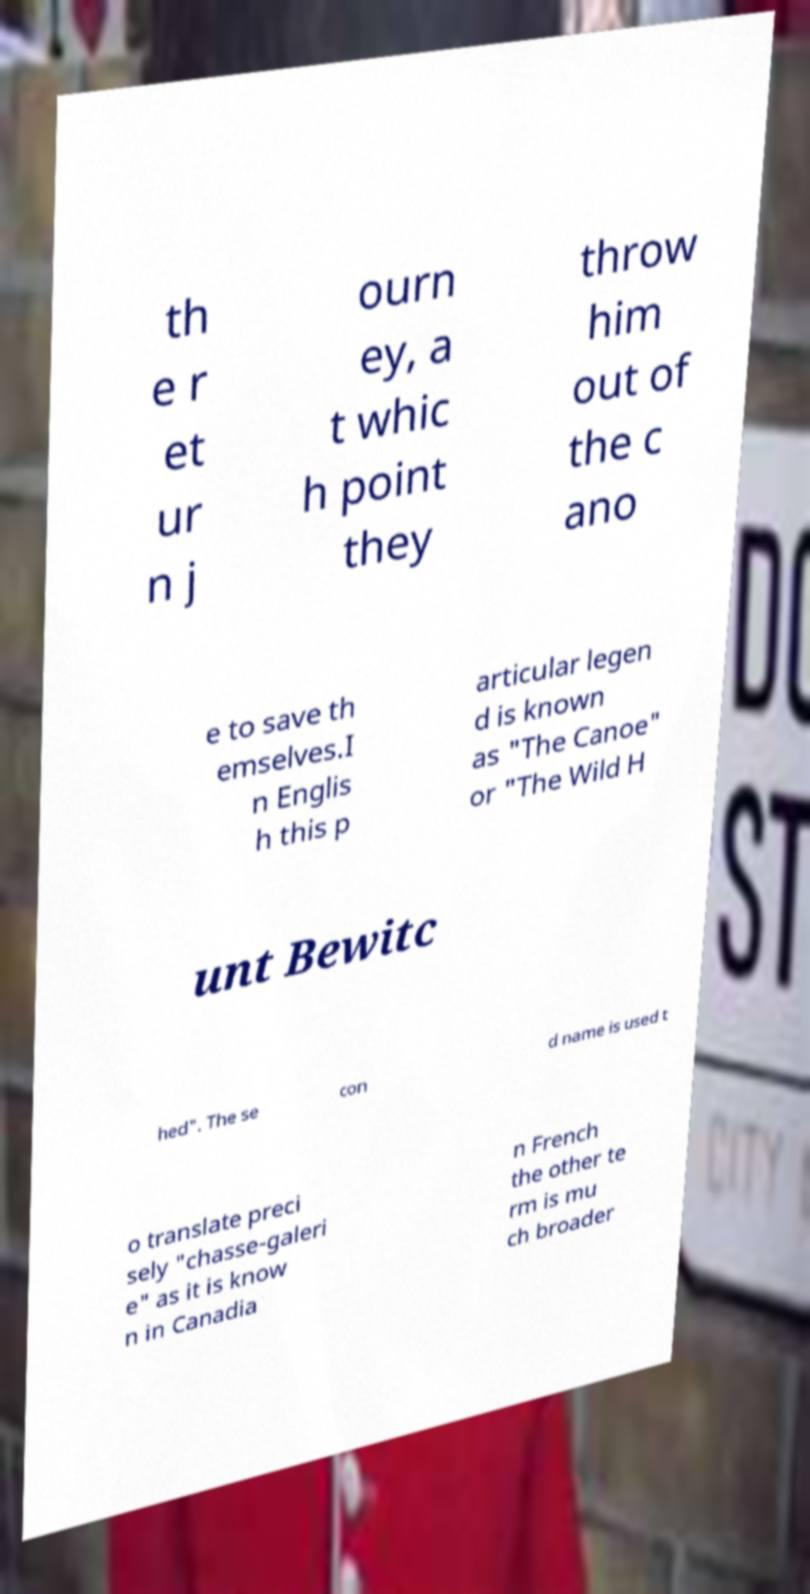Could you extract and type out the text from this image? th e r et ur n j ourn ey, a t whic h point they throw him out of the c ano e to save th emselves.I n Englis h this p articular legen d is known as "The Canoe" or "The Wild H unt Bewitc hed". The se con d name is used t o translate preci sely "chasse-galeri e" as it is know n in Canadia n French the other te rm is mu ch broader 